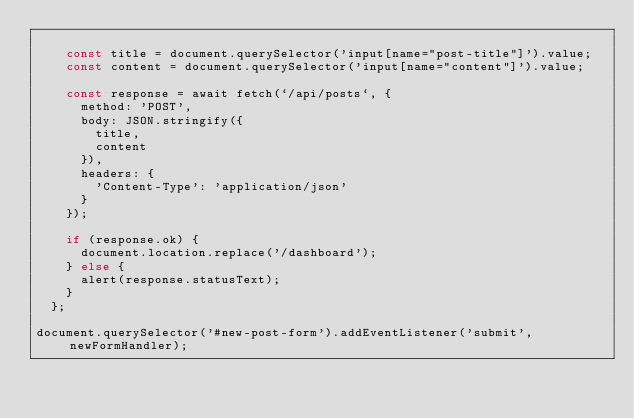Convert code to text. <code><loc_0><loc_0><loc_500><loc_500><_JavaScript_>  
    const title = document.querySelector('input[name="post-title"]').value;
    const content = document.querySelector('input[name="content"]').value;
  
    const response = await fetch(`/api/posts`, {
      method: 'POST',
      body: JSON.stringify({
        title,
        content
      }),
      headers: {
        'Content-Type': 'application/json'
      }
    });
  
    if (response.ok) {
      document.location.replace('/dashboard');
    } else {
      alert(response.statusText);
    }
  };
  
document.querySelector('#new-post-form').addEventListener('submit', newFormHandler);</code> 